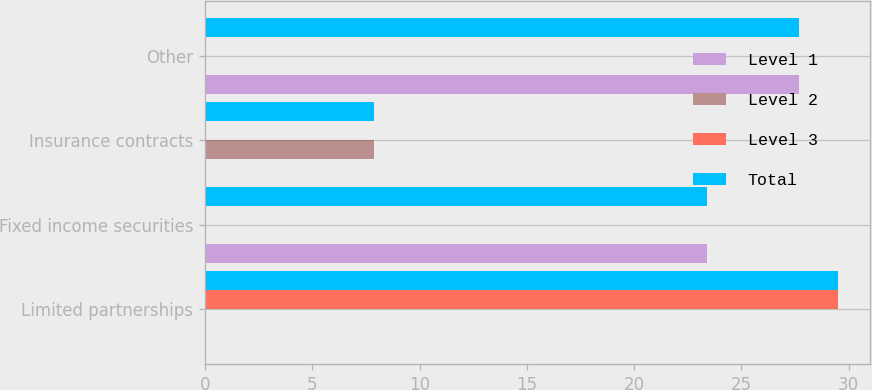Convert chart. <chart><loc_0><loc_0><loc_500><loc_500><stacked_bar_chart><ecel><fcel>Limited partnerships<fcel>Fixed income securities<fcel>Insurance contracts<fcel>Other<nl><fcel>Level 1<fcel>0<fcel>23.4<fcel>0<fcel>27.7<nl><fcel>Level 2<fcel>0<fcel>0<fcel>7.9<fcel>0<nl><fcel>Level 3<fcel>29.5<fcel>0<fcel>0<fcel>0<nl><fcel>Total<fcel>29.5<fcel>23.4<fcel>7.9<fcel>27.7<nl></chart> 